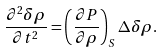<formula> <loc_0><loc_0><loc_500><loc_500>\frac { \partial ^ { 2 } \delta \rho } { \partial t ^ { 2 } } = \left ( \frac { \partial P } { \partial \rho } \right ) _ { S } \Delta \delta \rho .</formula> 